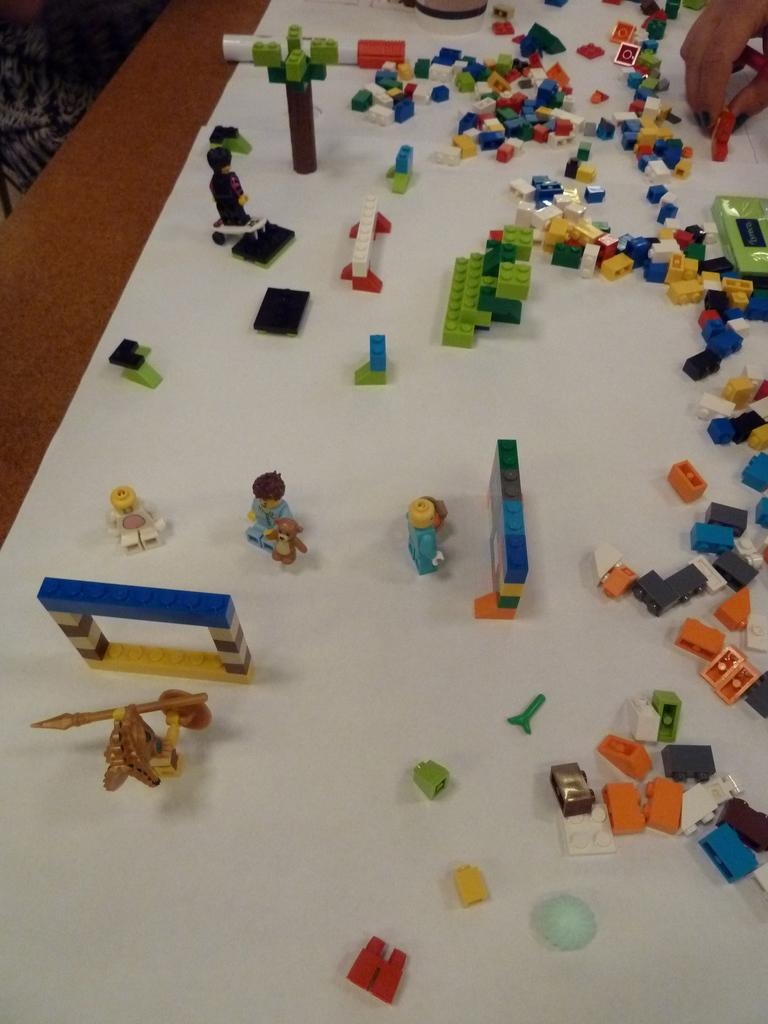What objects are present in the image? There are toys in the image. What is the color of the surface on which the toys are placed? The toys are on a white surface. What type of oatmeal is being prepared by the actor in the image? There is no oatmeal or actor present in the image; it only features toys on a white surface. 